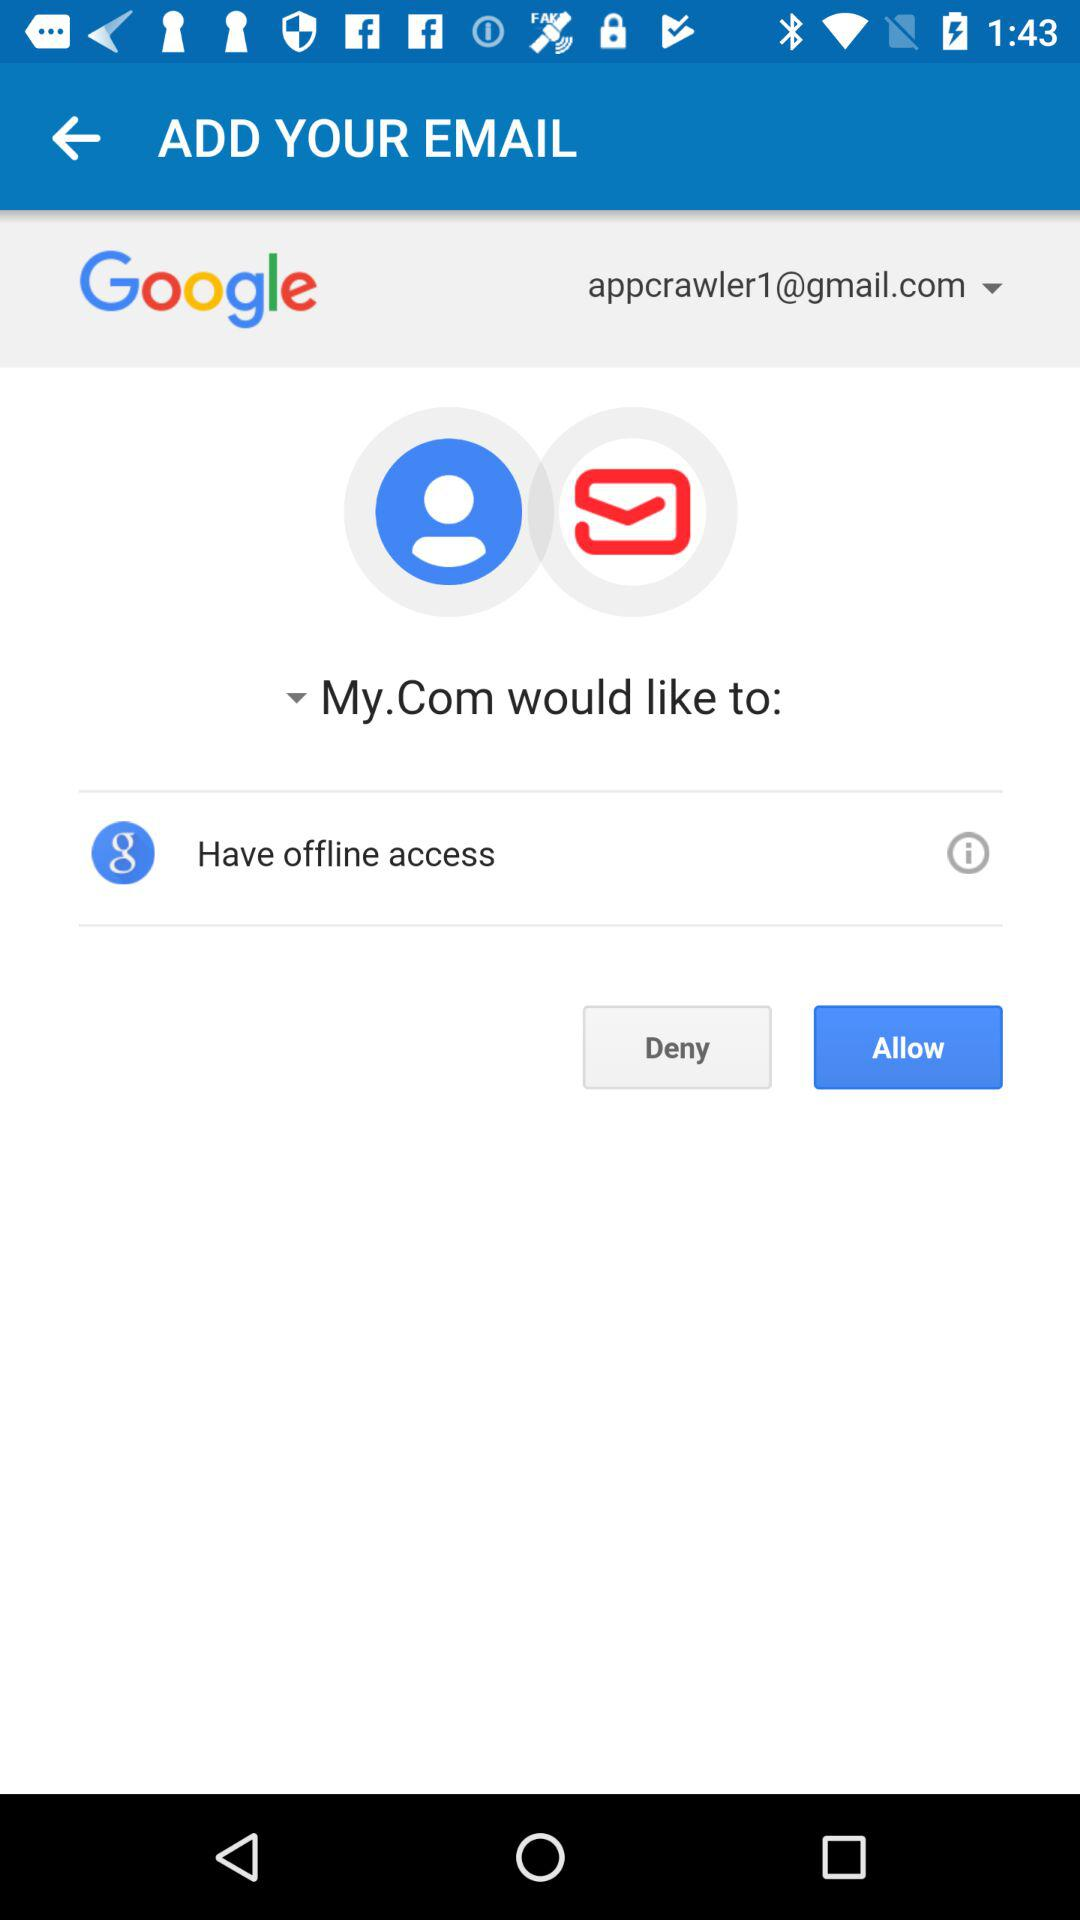What is the email address? The email address is appcrawler1@gmail.com. 